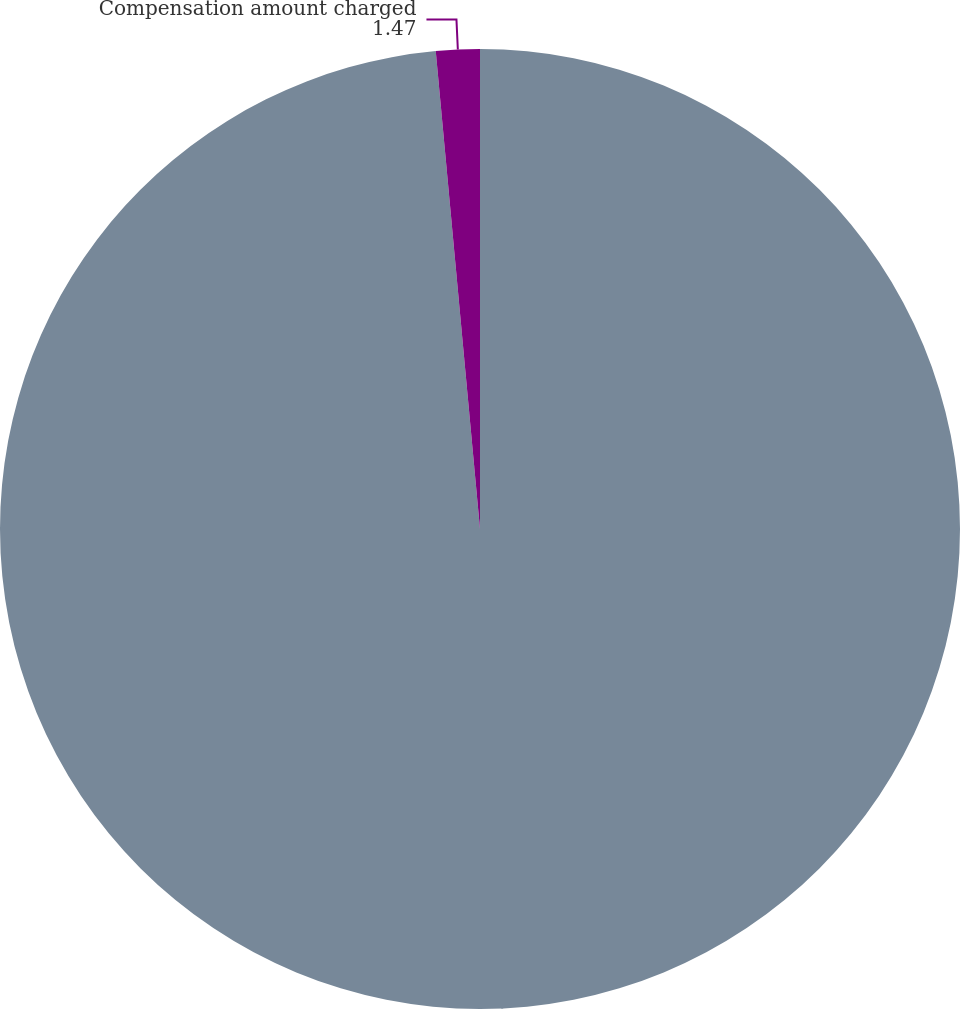<chart> <loc_0><loc_0><loc_500><loc_500><pie_chart><fcel>For the years ended December<fcel>Compensation amount charged<nl><fcel>98.53%<fcel>1.47%<nl></chart> 